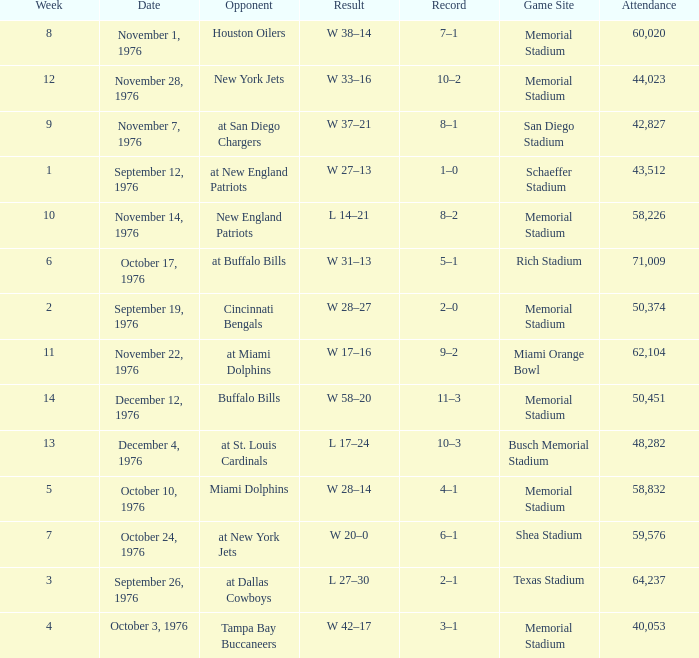How many people attended the game at the miami orange bowl? 62104.0. 